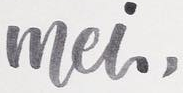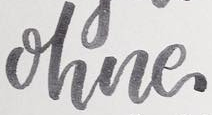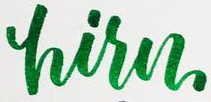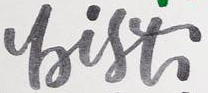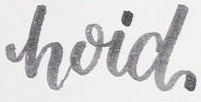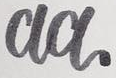Identify the words shown in these images in order, separated by a semicolon. mei,; ohne; hisn; bist; hoid; aa 